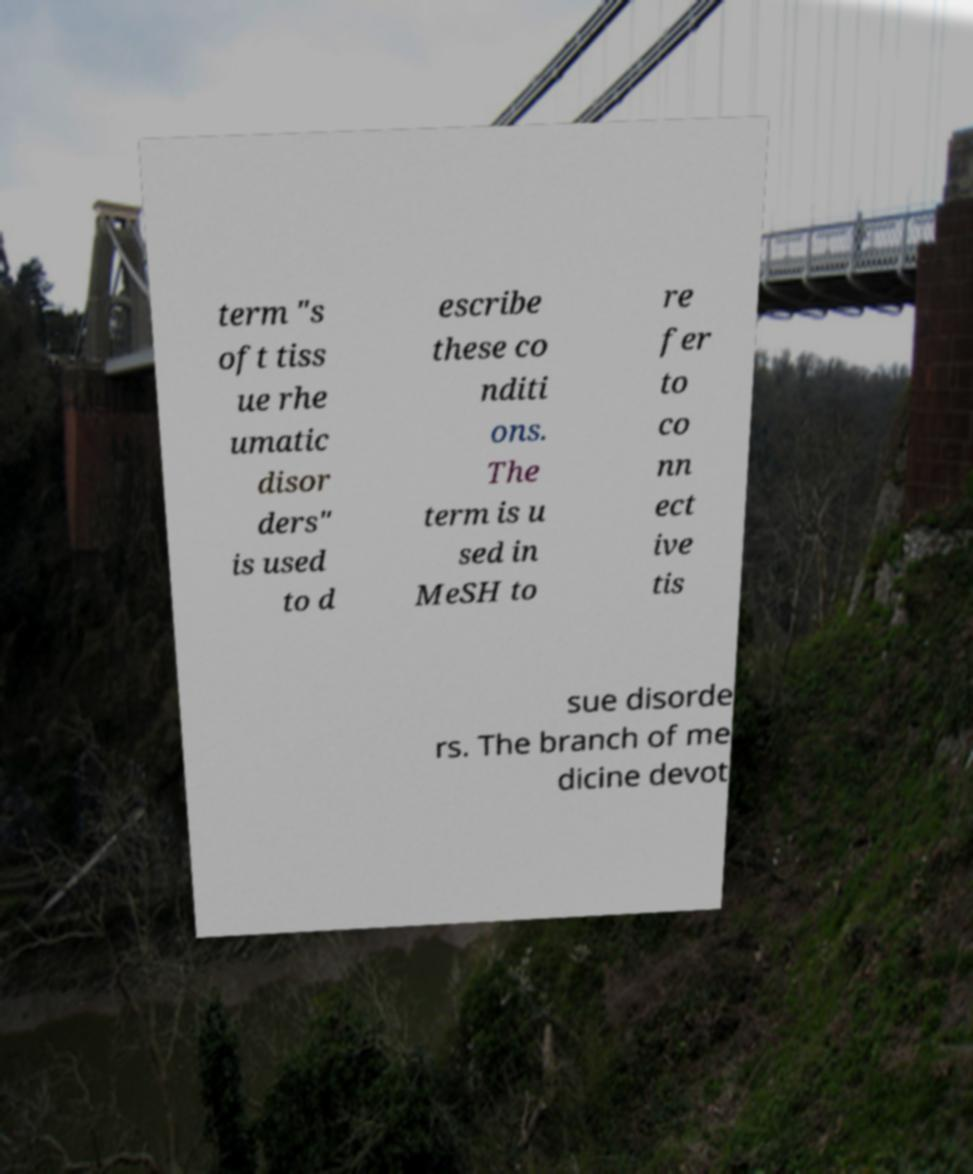What messages or text are displayed in this image? I need them in a readable, typed format. term "s oft tiss ue rhe umatic disor ders" is used to d escribe these co nditi ons. The term is u sed in MeSH to re fer to co nn ect ive tis sue disorde rs. The branch of me dicine devot 